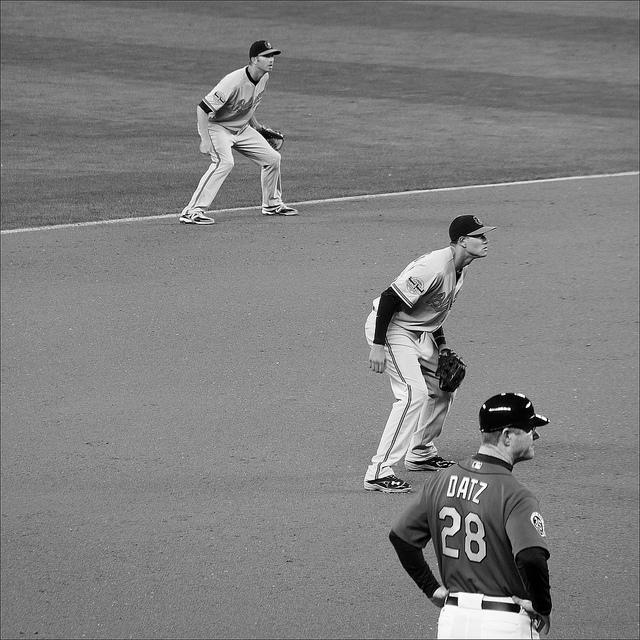How many people can be seen?
Give a very brief answer. 3. How many ski lifts are to the right of the man in the yellow coat?
Give a very brief answer. 0. 